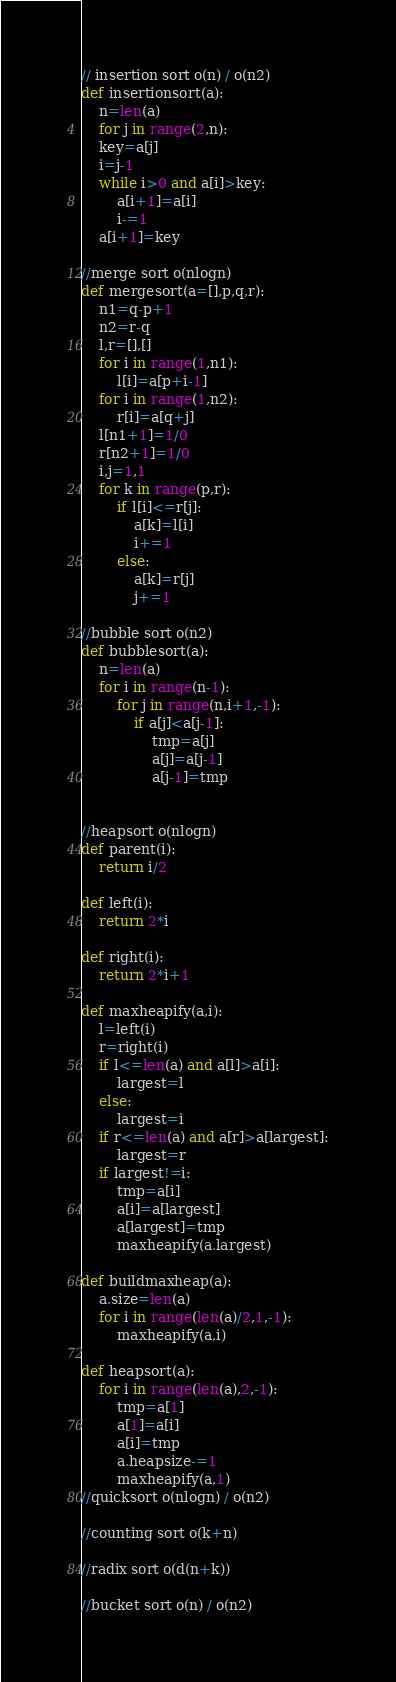Convert code to text. <code><loc_0><loc_0><loc_500><loc_500><_Python_>// insertion sort o(n) / o(n2)
def insertionsort(a):
    n=len(a)
    for j in range(2,n):
    key=a[j]
    i=j-1
    while i>0 and a[i]>key:
        a[i+1]=a[i]
        i-=1
    a[i+1]=key

//merge sort o(nlogn)
def mergesort(a=[],p,q,r):
    n1=q-p+1
    n2=r-q
    l,r=[],[]
    for i in range(1,n1):
        l[i]=a[p+i-1]
    for i in range(1,n2):
        r[i]=a[q+j]
    l[n1+1]=1/0
    r[n2+1]=1/0
    i,j=1,1
    for k in range(p,r):
        if l[i]<=r[j]:
            a[k]=l[i]
            i+=1
        else:
            a[k]=r[j]
            j+=1

//bubble sort o(n2)
def bubblesort(a):
    n=len(a)
    for i in range(n-1):
        for j in range(n,i+1,-1):
            if a[j]<a[j-1]:
                tmp=a[j]
                a[j]=a[j-1]
                a[j-1]=tmp


//heapsort o(nlogn)
def parent(i):
    return i/2

def left(i):
    return 2*i

def right(i):
    return 2*i+1

def maxheapify(a,i):
    l=left(i)
    r=right(i)
    if l<=len(a) and a[l]>a[i]:
        largest=l
    else:
        largest=i
    if r<=len(a) and a[r]>a[largest]:
        largest=r
    if largest!=i:
        tmp=a[i]
        a[i]=a[largest]
        a[largest]=tmp
        maxheapify(a.largest)

def buildmaxheap(a):
    a.size=len(a)
    for i in range(len(a)/2,1,-1):
        maxheapify(a,i)

def heapsort(a):
    for i in range(len(a),2,-1):
        tmp=a[1]
        a[1]=a[i]
        a[i]=tmp
        a.heapsize-=1
        maxheapify(a,1)
//quicksort o(nlogn) / o(n2)

//counting sort o(k+n)

//radix sort o(d(n+k))

//bucket sort o(n) / o(n2)
</code> 